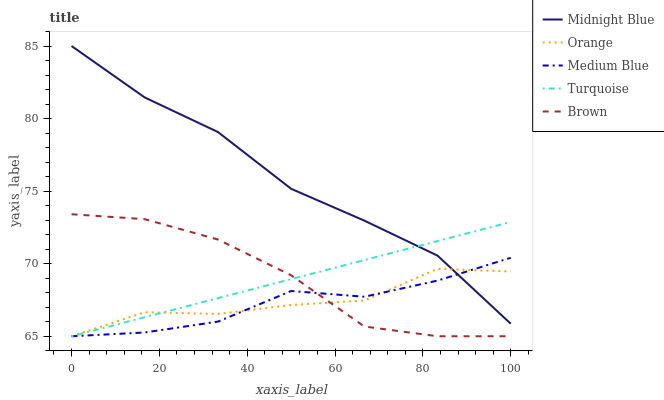Does Brown have the minimum area under the curve?
Answer yes or no. No. Does Brown have the maximum area under the curve?
Answer yes or no. No. Is Brown the smoothest?
Answer yes or no. No. Is Brown the roughest?
Answer yes or no. No. Does Midnight Blue have the lowest value?
Answer yes or no. No. Does Brown have the highest value?
Answer yes or no. No. Is Brown less than Midnight Blue?
Answer yes or no. Yes. Is Midnight Blue greater than Brown?
Answer yes or no. Yes. Does Brown intersect Midnight Blue?
Answer yes or no. No. 